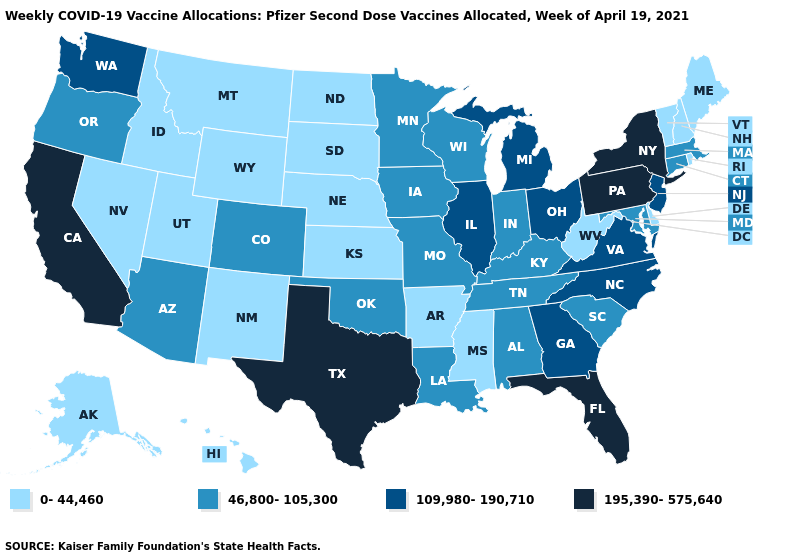Among the states that border Virginia , does Maryland have the highest value?
Concise answer only. No. What is the highest value in the Northeast ?
Keep it brief. 195,390-575,640. Name the states that have a value in the range 109,980-190,710?
Short answer required. Georgia, Illinois, Michigan, New Jersey, North Carolina, Ohio, Virginia, Washington. Among the states that border Massachusetts , does New York have the lowest value?
Keep it brief. No. Name the states that have a value in the range 195,390-575,640?
Short answer required. California, Florida, New York, Pennsylvania, Texas. What is the highest value in the Northeast ?
Short answer required. 195,390-575,640. Which states have the highest value in the USA?
Short answer required. California, Florida, New York, Pennsylvania, Texas. What is the value of Mississippi?
Answer briefly. 0-44,460. Does the map have missing data?
Be succinct. No. Among the states that border Colorado , which have the highest value?
Keep it brief. Arizona, Oklahoma. Does the map have missing data?
Write a very short answer. No. Does North Dakota have the lowest value in the USA?
Be succinct. Yes. Among the states that border Minnesota , which have the highest value?
Be succinct. Iowa, Wisconsin. Does Nebraska have the same value as California?
Quick response, please. No. Which states have the highest value in the USA?
Short answer required. California, Florida, New York, Pennsylvania, Texas. 